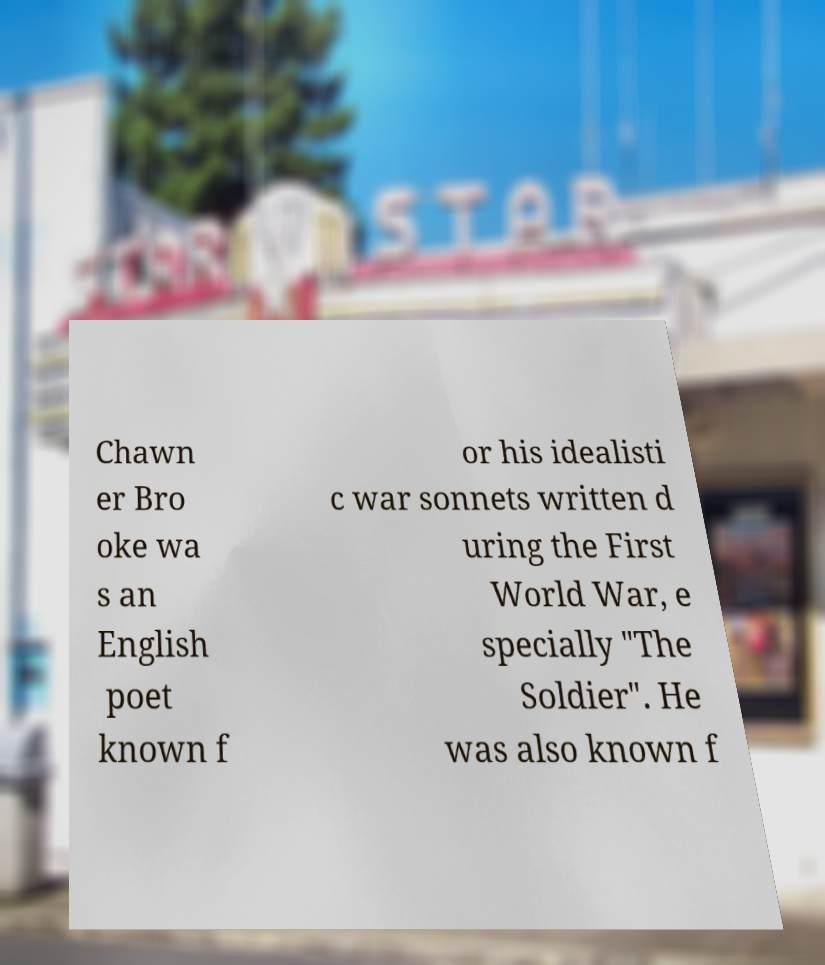For documentation purposes, I need the text within this image transcribed. Could you provide that? Chawn er Bro oke wa s an English poet known f or his idealisti c war sonnets written d uring the First World War, e specially "The Soldier". He was also known f 